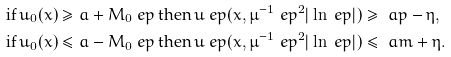<formula> <loc_0><loc_0><loc_500><loc_500>& \text {if} \, u _ { 0 } ( x ) \geq a + M _ { 0 } \ e p \, \text {then} \, u ^ { \ } e p ( x , \mu ^ { - 1 } \ e p ^ { 2 } | \ln \ e p | ) \geq \ a p - \eta , \\ & \text {if} \, u _ { 0 } ( x ) \leq a - M _ { 0 } \ e p \, \text {then} \, u ^ { \ } e p ( x , \mu ^ { - 1 } \ e p ^ { 2 } | \ln \ e p | ) \leq \ a m + \eta .</formula> 